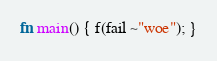<code> <loc_0><loc_0><loc_500><loc_500><_Rust_>
fn main() { f(fail ~"woe"); }
</code> 